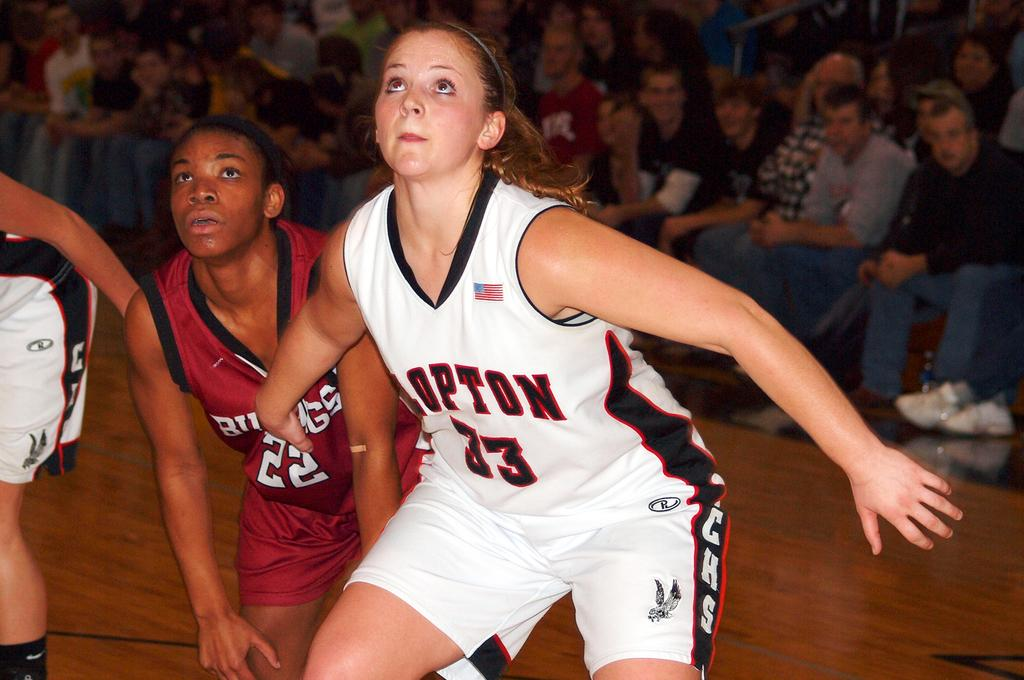Provide a one-sentence caption for the provided image. multiple women playing basketball in uniform and the audience watchin. 